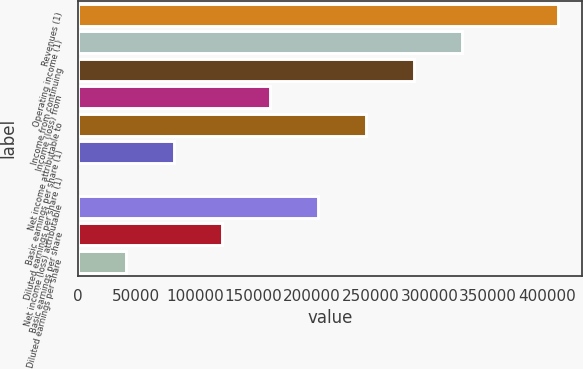<chart> <loc_0><loc_0><loc_500><loc_500><bar_chart><fcel>Revenues (1)<fcel>Operating income (1)<fcel>Income from continuing<fcel>Income (loss) from<fcel>Net income attributable to<fcel>Basic earnings per share (1)<fcel>Diluted earnings per share (1)<fcel>Net income (loss) attributable<fcel>Basic earnings per share<fcel>Diluted earnings per share<nl><fcel>409932<fcel>327946<fcel>286953<fcel>163973<fcel>245959<fcel>81987<fcel>0.71<fcel>204966<fcel>122980<fcel>40993.8<nl></chart> 